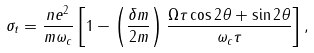Convert formula to latex. <formula><loc_0><loc_0><loc_500><loc_500>\sigma _ { t } = \frac { n e ^ { 2 } } { m \omega _ { c } } \left [ 1 - \left ( \frac { \delta m } { 2 m } \right ) \frac { \Omega \tau \cos 2 \theta + \sin 2 \theta } { \omega _ { c } \tau } \right ] ,</formula> 